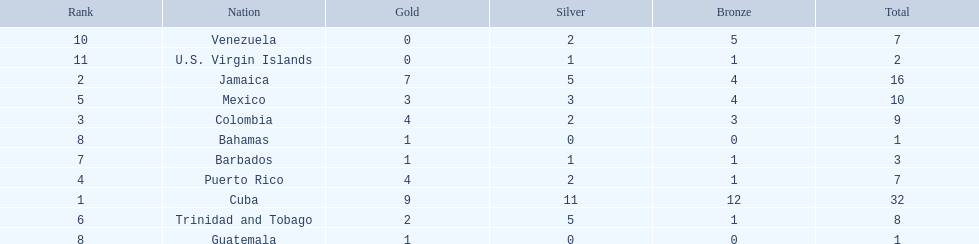Which country was awarded more than 5 silver medals? Cuba. 